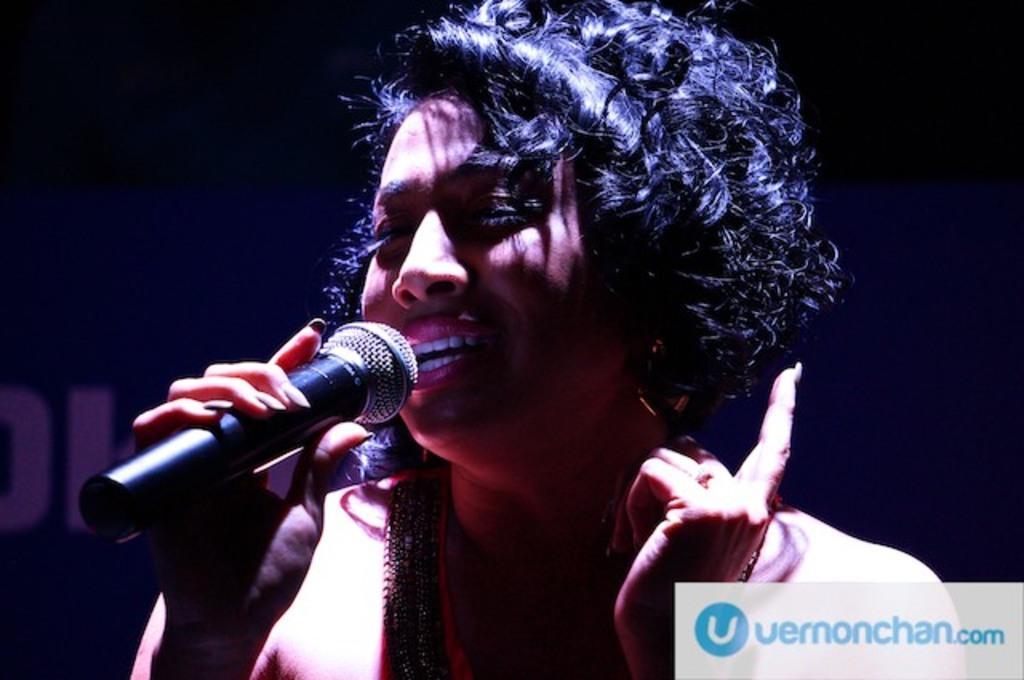Can you describe this image briefly? In the middle of the image a woman is standing and holding a microphone and singing. 